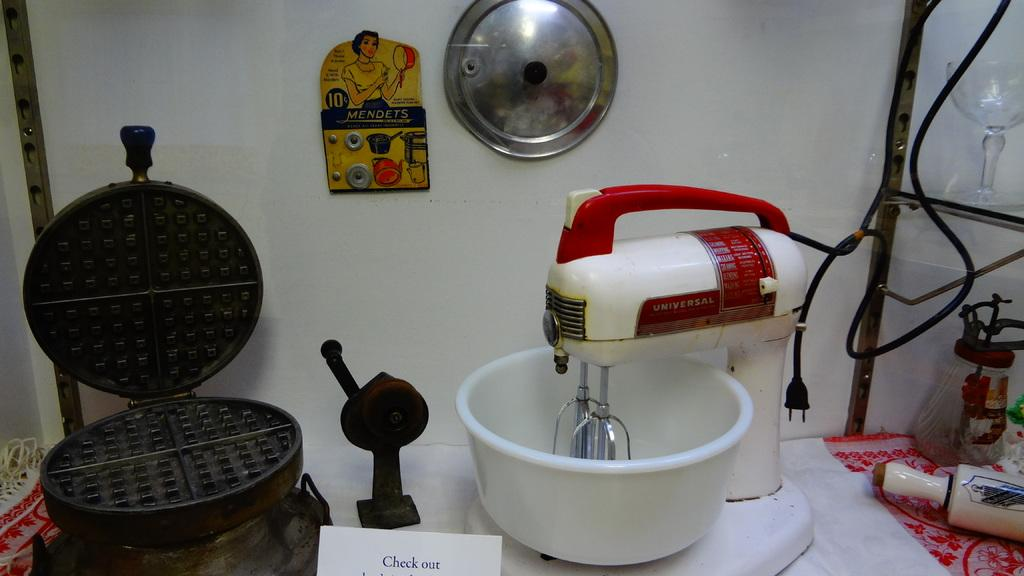<image>
Share a concise interpretation of the image provided. a waffle iron and mixer with a sign reading Check Out 